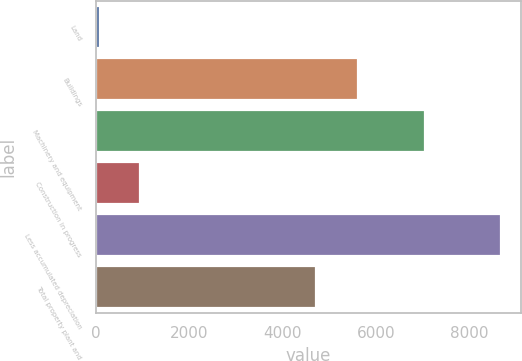Convert chart. <chart><loc_0><loc_0><loc_500><loc_500><bar_chart><fcel>Land<fcel>Buildings<fcel>Machinery and equipment<fcel>Construction in progress<fcel>Less accumulated depreciation<fcel>Total property plant and<nl><fcel>99<fcel>5602<fcel>7043<fcel>955.1<fcel>8660<fcel>4706<nl></chart> 